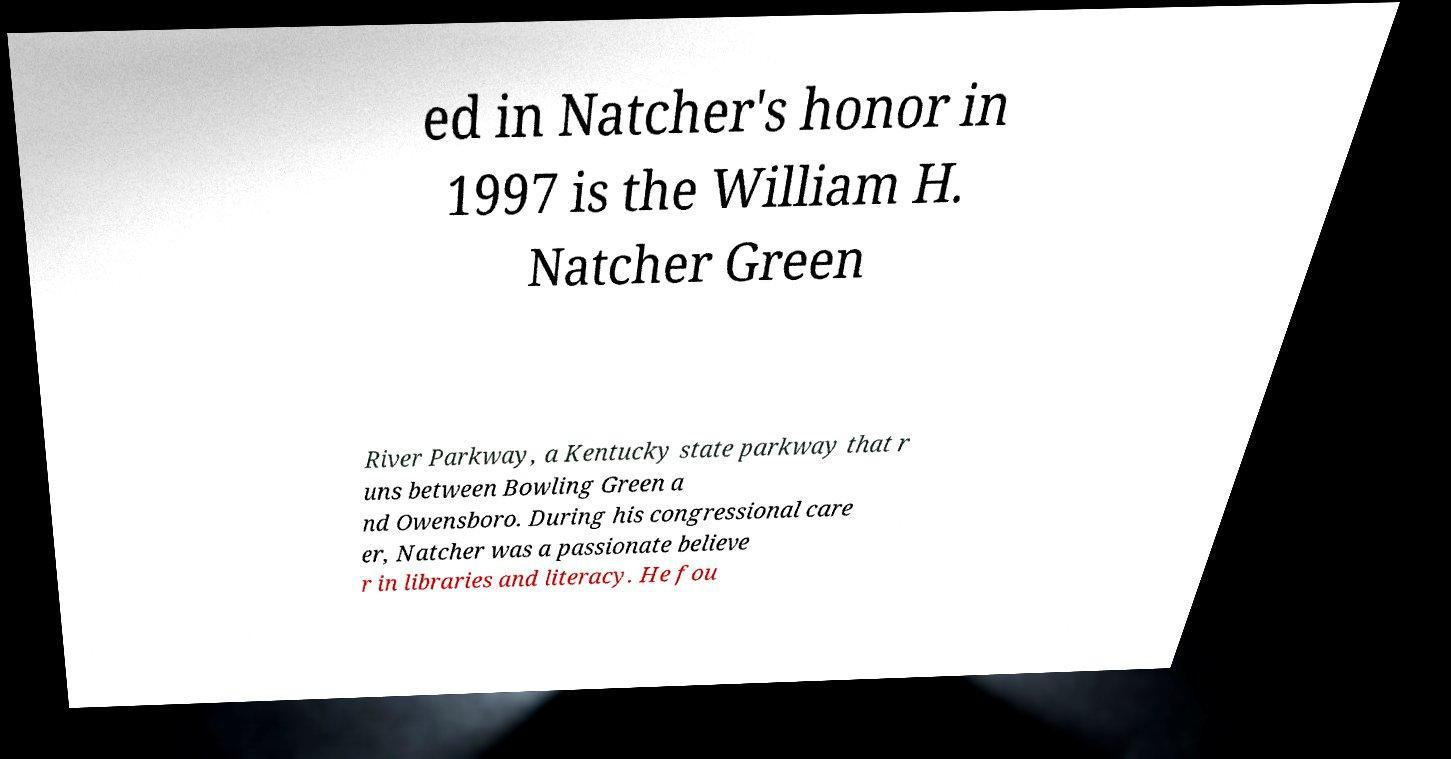There's text embedded in this image that I need extracted. Can you transcribe it verbatim? ed in Natcher's honor in 1997 is the William H. Natcher Green River Parkway, a Kentucky state parkway that r uns between Bowling Green a nd Owensboro. During his congressional care er, Natcher was a passionate believe r in libraries and literacy. He fou 